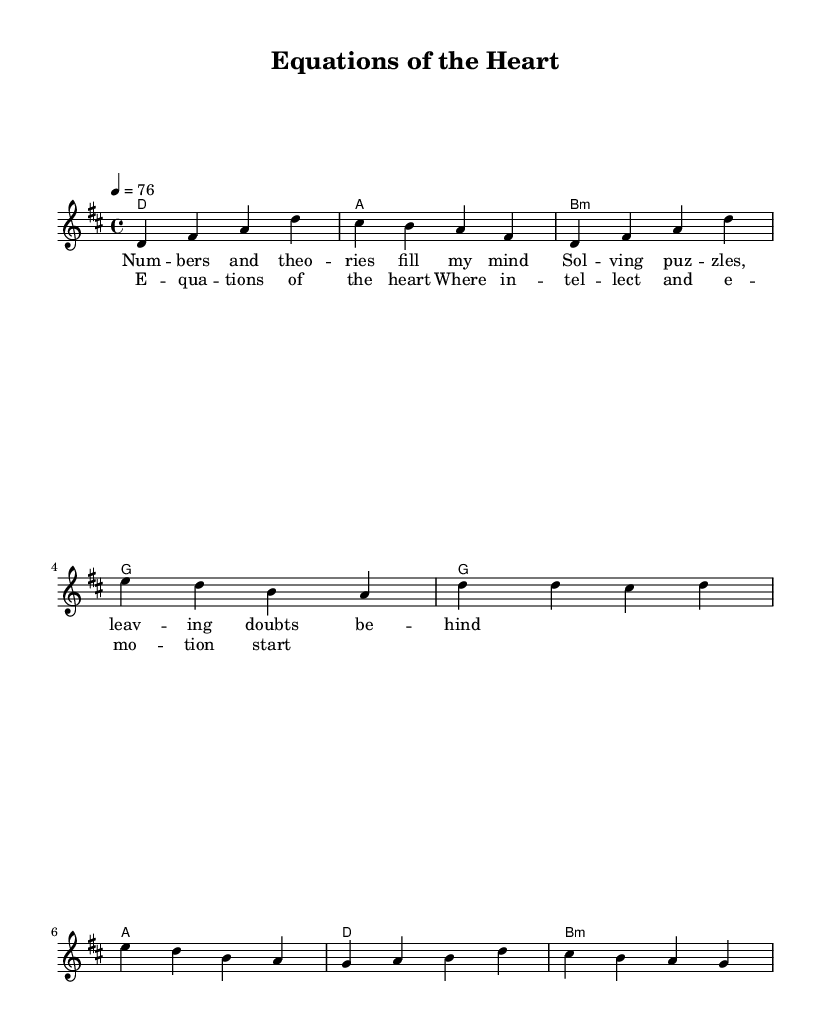What is the key signature of this music? The key signature is indicated at the beginning of the staff with one sharp. This corresponds to D major, which contains the notes D, E, F sharp, G, A, B, and C sharp.
Answer: D major What is the time signature of this piece? The time signature, found at the beginning of the staff, shows a 4 over 4, indicating that there are four beats per measure and the quarter note gets one beat.
Answer: 4/4 What is the tempo marking for this piece? The tempo marking is indicated by the "tempo 4 = 76" at the beginning, meaning the piece should be played at a speed of 76 beats per minute.
Answer: 76 BPM How many measures are in the verse? By counting the measures indicated in the melody line, we see that there are four measures designated as the verse before transitioning to the chorus.
Answer: 4 What are the first two chords in the verse? The first two chords listed in the harmonies section are D and A, which are found at the start of the verse indicating the harmonic foundation.
Answer: D and A Is this song a ballad? The song's title and lyrics both suggest a focus on emotional topics, characteristic of ballads, which usually convey deeper personal experiences and growth, particularly in the context of rock music.
Answer: Yes 